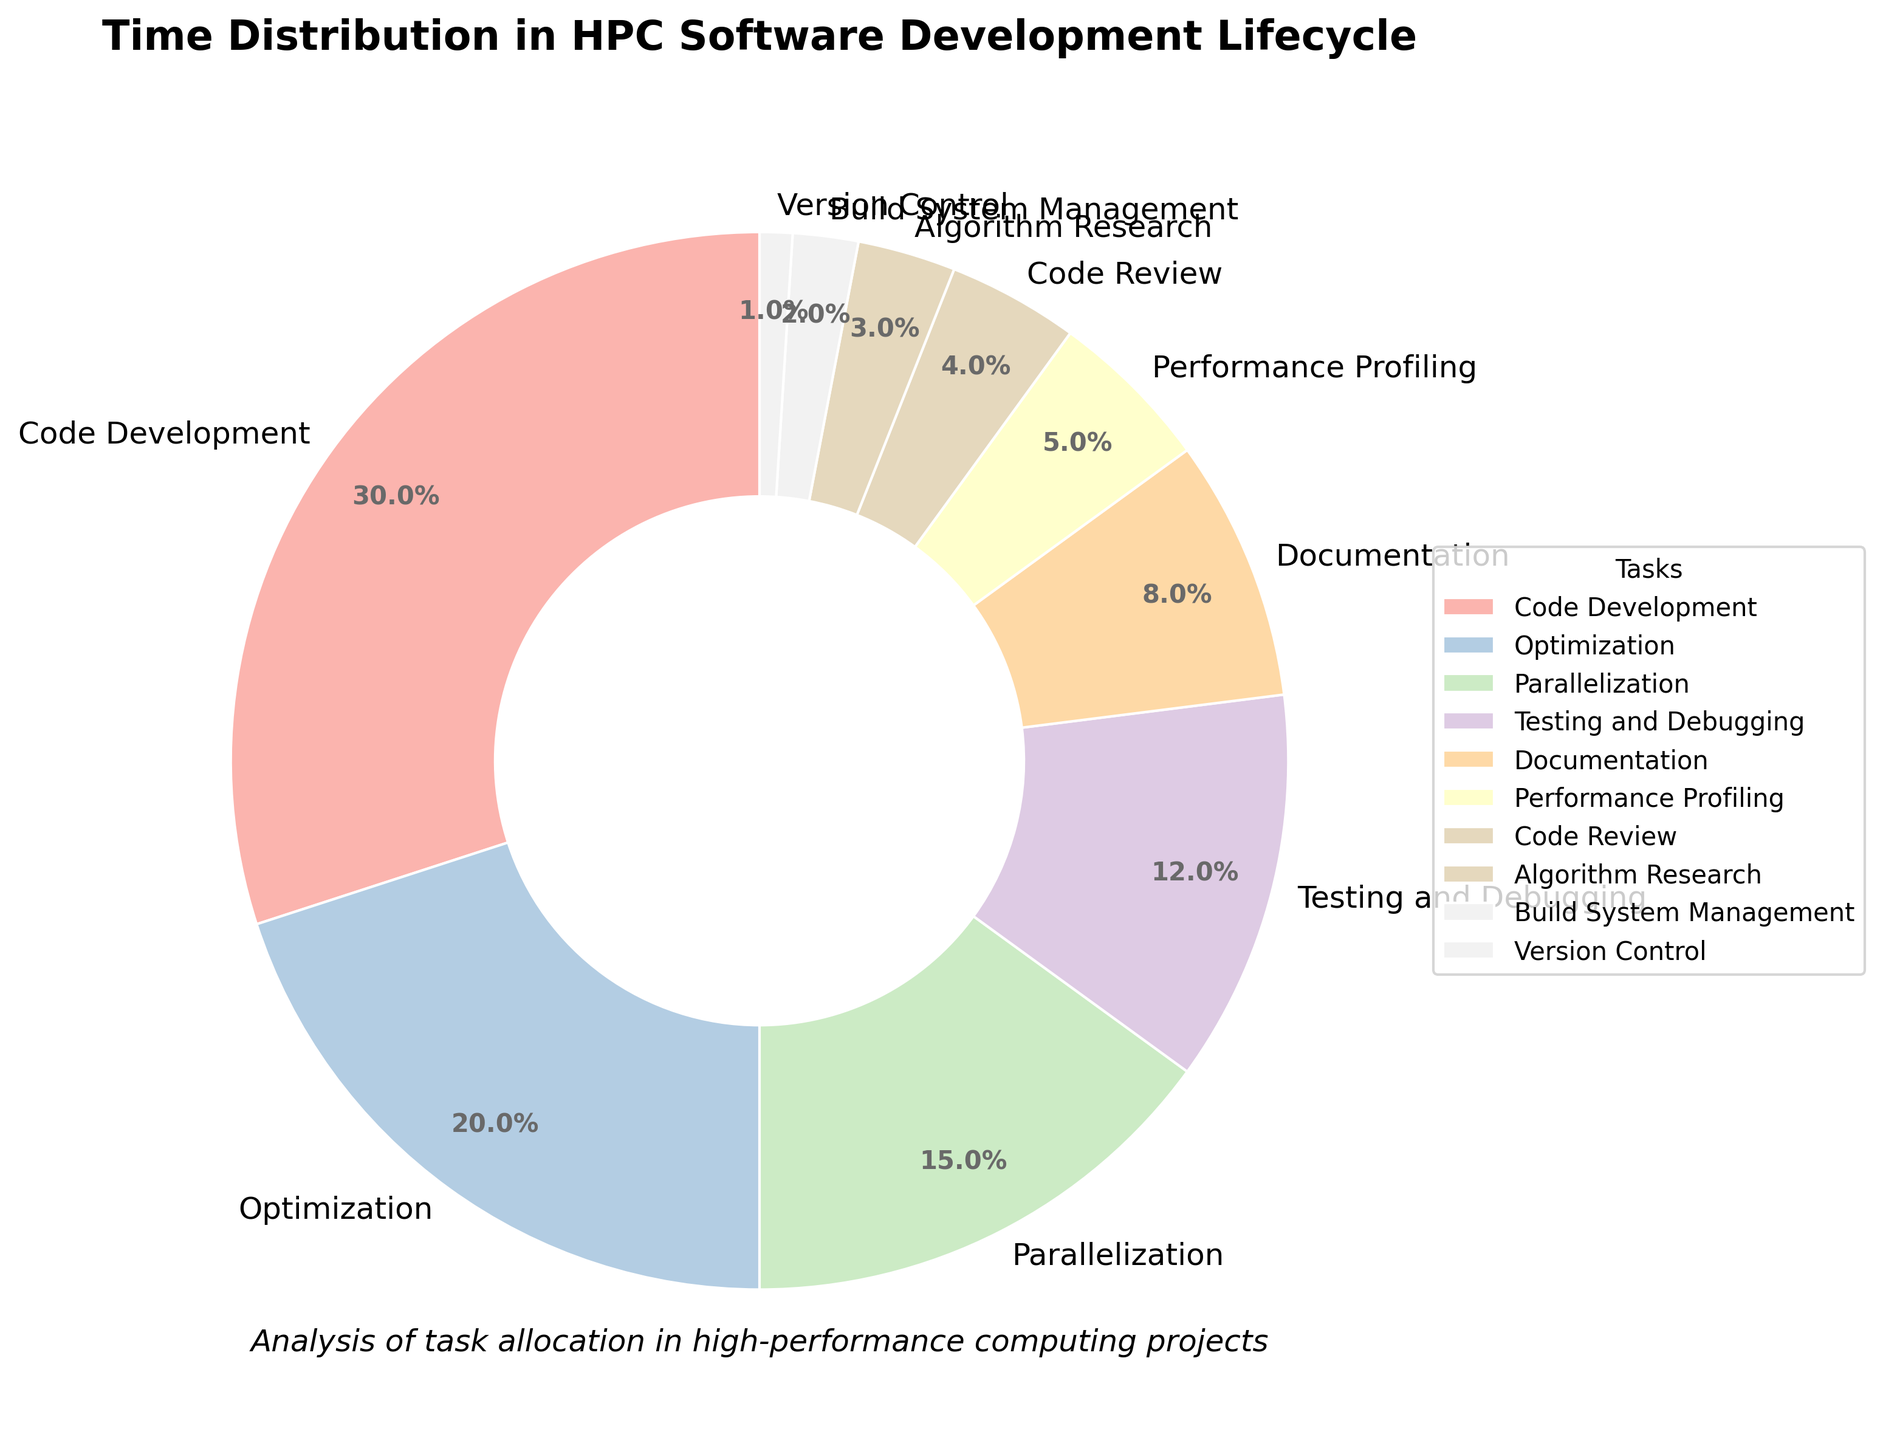Which task takes the most time in the HPC software development lifecycle? Code Development takes 30% of the time, the largest slice of the pie chart indicating it's the most time-consuming task.
Answer: Code Development Which two tasks take up the least amount of time combined? Version Control takes 1% and Build System Management takes 2%. Their combined time is 1% + 2% = 3%.
Answer: Version Control and Build System Management Are there more tasks taking up more than 10% of time or less than 10% of time? Tasks more than 10%: Code Development (30%), Optimization (20%), Parallelization (15%). Tasks less than 10%: Testing and Debugging (12%), Documentation (8%), Performance Profiling (5%), Code Review (4%), Algorithm Research (3%), Build System Management (2%), Version Control (1%). There are 3 tasks > 10% and 7 tasks < 10%. More tasks take up less than 10% of time.
Answer: Less than 10% Which tasks combined take up exactly half of the total time? Summing up the percentages: Code Development (30%) + Optimization (20%) = 50%.
Answer: Code Development and Optimization How much more time is spent on Performance Profiling than on Code Review? Performance Profiling takes 5% and Code Review takes 4%. The difference is 5% - 4% = 1%.
Answer: 1% What percentage of time is dedicated to tasks related to improving performance (Optimization, Parallelization, Performance Profiling)? Adding percentages: Optimization (20%) + Parallelization (15%) + Performance Profiling (5%) = 40%.
Answer: 40% Which task’s time distribution is visually represented by the lightest color slice in the pie chart? Since a custom color palette is used, the task with the smallest percentage, Version Control at 1%, is visually represented by the lightest slice typically.
Answer: Version Control Is more time spent on Testing and Debugging or on Documentation? Testing and Debugging takes 12%, while Documentation takes 8%, so more time is spent on Testing and Debugging.
Answer: Testing and Debugging If the time spent on Code Review was doubled, would Code Review have a larger share than Parallelization? Current time for Code Review is 4%. If doubled, it becomes 8%. Parallelization takes 15%. Hence, it will still be less than Parallelization.
Answer: No 